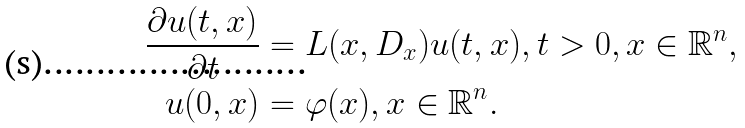Convert formula to latex. <formula><loc_0><loc_0><loc_500><loc_500>\frac { \partial u ( t , x ) } { \partial t } & = L ( x , D _ { x } ) u ( t , x ) , t > 0 , x \in \mathbb { R } ^ { n } , \\ u ( 0 , x ) & = \varphi ( x ) , x \in \mathbb { R } ^ { n } .</formula> 